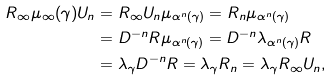Convert formula to latex. <formula><loc_0><loc_0><loc_500><loc_500>R _ { \infty } \mu _ { \infty } ( \gamma ) U _ { n } & = R _ { \infty } U _ { n } \mu _ { \alpha ^ { n } ( \gamma ) } = R _ { n } \mu _ { \alpha ^ { n } ( \gamma ) } \\ & = D ^ { - n } R \mu _ { \alpha ^ { n } ( \gamma ) } = D ^ { - n } \lambda _ { \alpha ^ { n } ( \gamma ) } R \\ & = \lambda _ { \gamma } D ^ { - n } R = \lambda _ { \gamma } R _ { n } = \lambda _ { \gamma } R _ { \infty } U _ { n } ,</formula> 